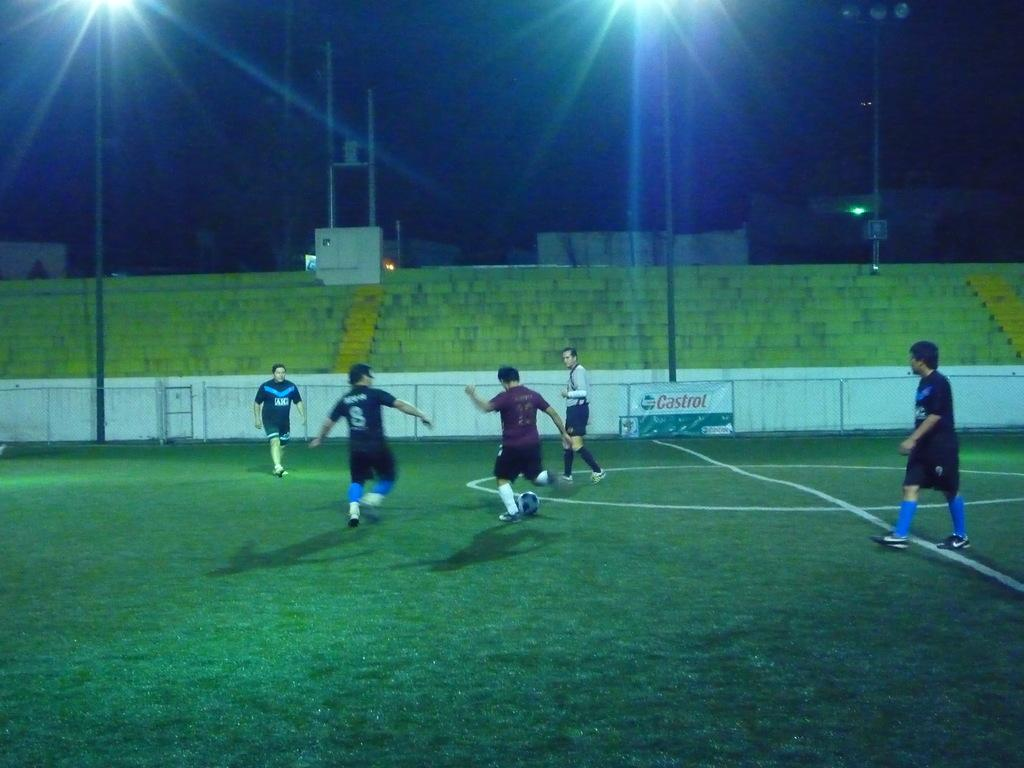<image>
Create a compact narrative representing the image presented. Men play soccer at night on a field sponsored by Castrol. 